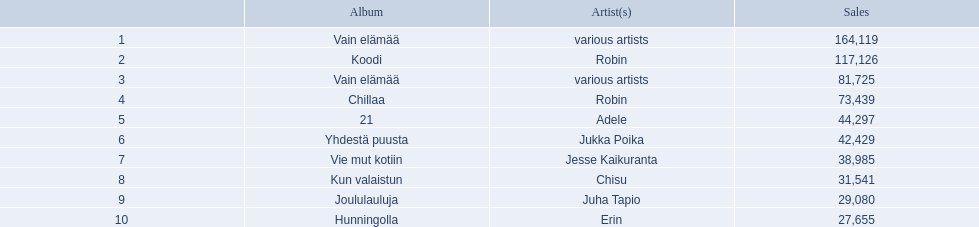What sales numbers does adele have? 44,297. Would you mind parsing the complete table? {'header': ['', 'Album', 'Artist(s)', 'Sales'], 'rows': [['1', 'Vain elämää', 'various artists', '164,119'], ['2', 'Koodi', 'Robin', '117,126'], ['3', 'Vain elämää', 'various artists', '81,725'], ['4', 'Chillaa', 'Robin', '73,439'], ['5', '21', 'Adele', '44,297'], ['6', 'Yhdestä puusta', 'Jukka Poika', '42,429'], ['7', 'Vie mut kotiin', 'Jesse Kaikuranta', '38,985'], ['8', 'Kun valaistun', 'Chisu', '31,541'], ['9', 'Joululauluja', 'Juha Tapio', '29,080'], ['10', 'Hunningolla', 'Erin', '27,655']]} What sales numbers does chisu have? 31,541. Which of these values is larger? 44,297. Who holds this count of sales? Adele. Who is the musician behind the 21 album? Adele. Who produced the kun valaistun album? Chisu. Could you parse the entire table as a dict? {'header': ['', 'Album', 'Artist(s)', 'Sales'], 'rows': [['1', 'Vain elämää', 'various artists', '164,119'], ['2', 'Koodi', 'Robin', '117,126'], ['3', 'Vain elämää', 'various artists', '81,725'], ['4', 'Chillaa', 'Robin', '73,439'], ['5', '21', 'Adele', '44,297'], ['6', 'Yhdestä puusta', 'Jukka Poika', '42,429'], ['7', 'Vie mut kotiin', 'Jesse Kaikuranta', '38,985'], ['8', 'Kun valaistun', 'Chisu', '31,541'], ['9', 'Joululauluja', 'Juha Tapio', '29,080'], ['10', 'Hunningolla', 'Erin', '27,655']]} Which album features the same artist as chillaa? Koodi. 